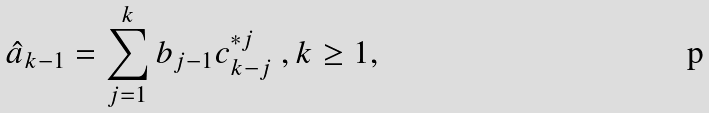Convert formula to latex. <formula><loc_0><loc_0><loc_500><loc_500>\hat { a } _ { k - 1 } = \sum _ { j = 1 } ^ { k } b _ { j - 1 } c ^ { * j } _ { k - j } \ , k \geq 1 ,</formula> 